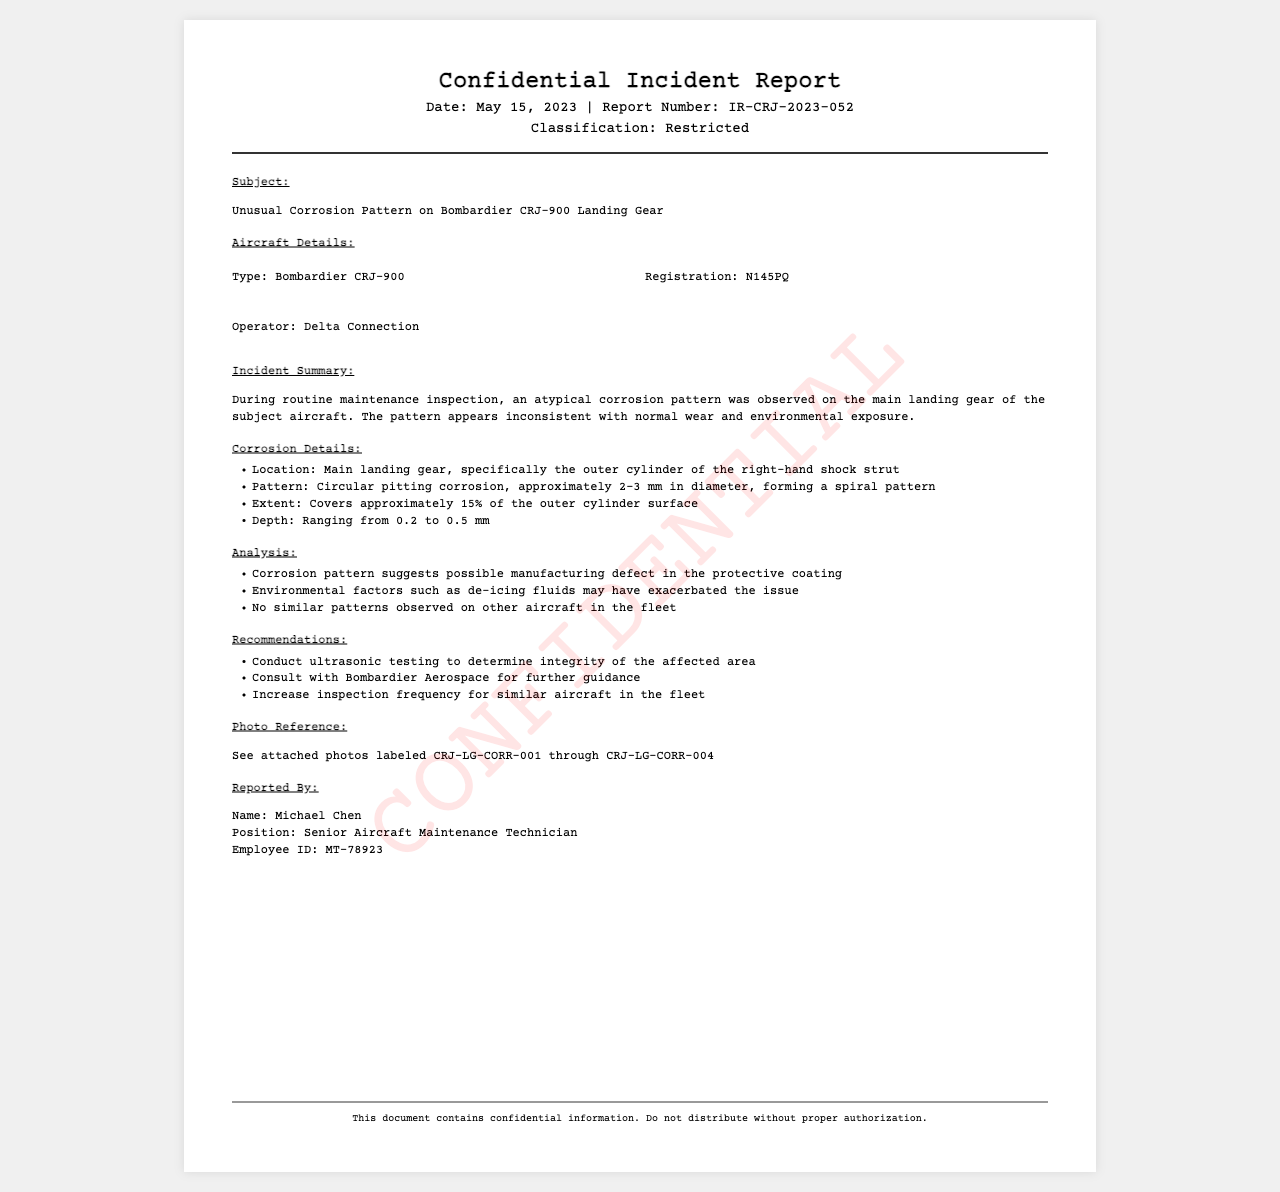What is the date of the incident report? The date is found in the header information of the document.
Answer: May 15, 2023 What is the registration number of the aircraft? The registration number is listed under Aircraft Details.
Answer: N145PQ What percentage of the outer cylinder surface is covered by corrosion? This information is specified in the Corrosion Details section of the report.
Answer: 15% What pattern does the corrosion follow? The pattern description is provided in the Corrosion Details section.
Answer: Spiral pattern Who reported the incident? The report specifies the name of the person who conducted the investigation.
Answer: Michael Chen What is recommended for the affected area? The recommendations section outlines an action to be taken regarding the corrosion.
Answer: Conduct ultrasonic testing What is the classification of this document? The classification is mentioned at the top of the report.
Answer: Restricted How many photos are referenced in the report? The document mentions the number of photo references included.
Answer: Four photos 